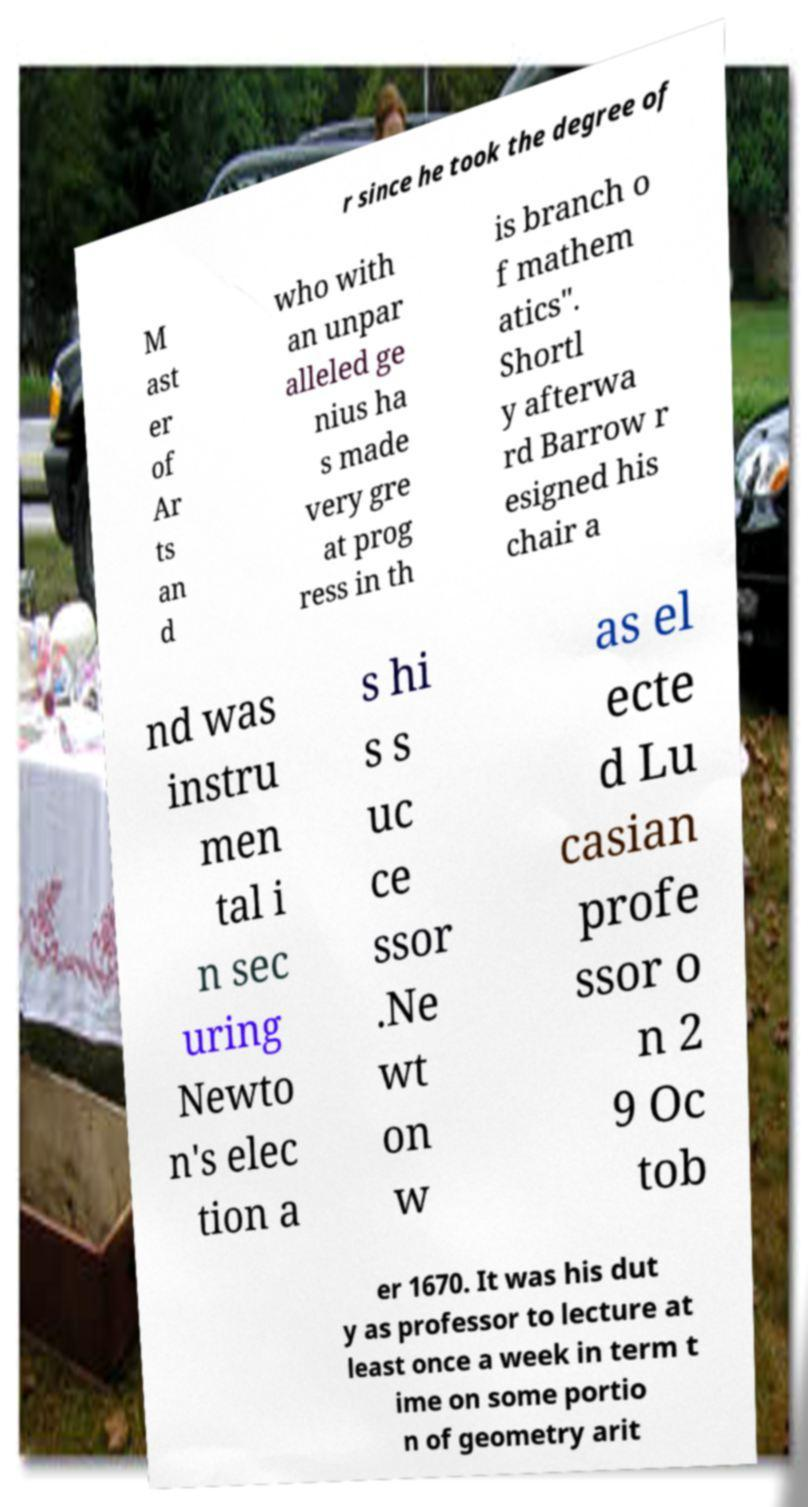Can you read and provide the text displayed in the image?This photo seems to have some interesting text. Can you extract and type it out for me? r since he took the degree of M ast er of Ar ts an d who with an unpar alleled ge nius ha s made very gre at prog ress in th is branch o f mathem atics". Shortl y afterwa rd Barrow r esigned his chair a nd was instru men tal i n sec uring Newto n's elec tion a s hi s s uc ce ssor .Ne wt on w as el ecte d Lu casian profe ssor o n 2 9 Oc tob er 1670. It was his dut y as professor to lecture at least once a week in term t ime on some portio n of geometry arit 